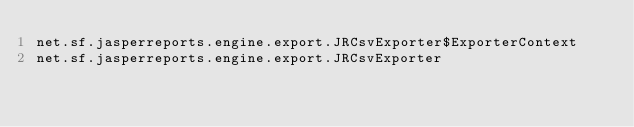<code> <loc_0><loc_0><loc_500><loc_500><_Rust_>net.sf.jasperreports.engine.export.JRCsvExporter$ExporterContext
net.sf.jasperreports.engine.export.JRCsvExporter
</code> 